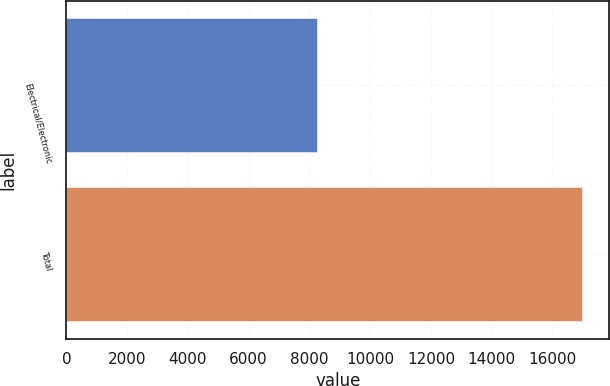Convert chart to OTSL. <chart><loc_0><loc_0><loc_500><loc_500><bar_chart><fcel>Electrical/Electronic<fcel>Total<nl><fcel>8274<fcel>17023<nl></chart> 